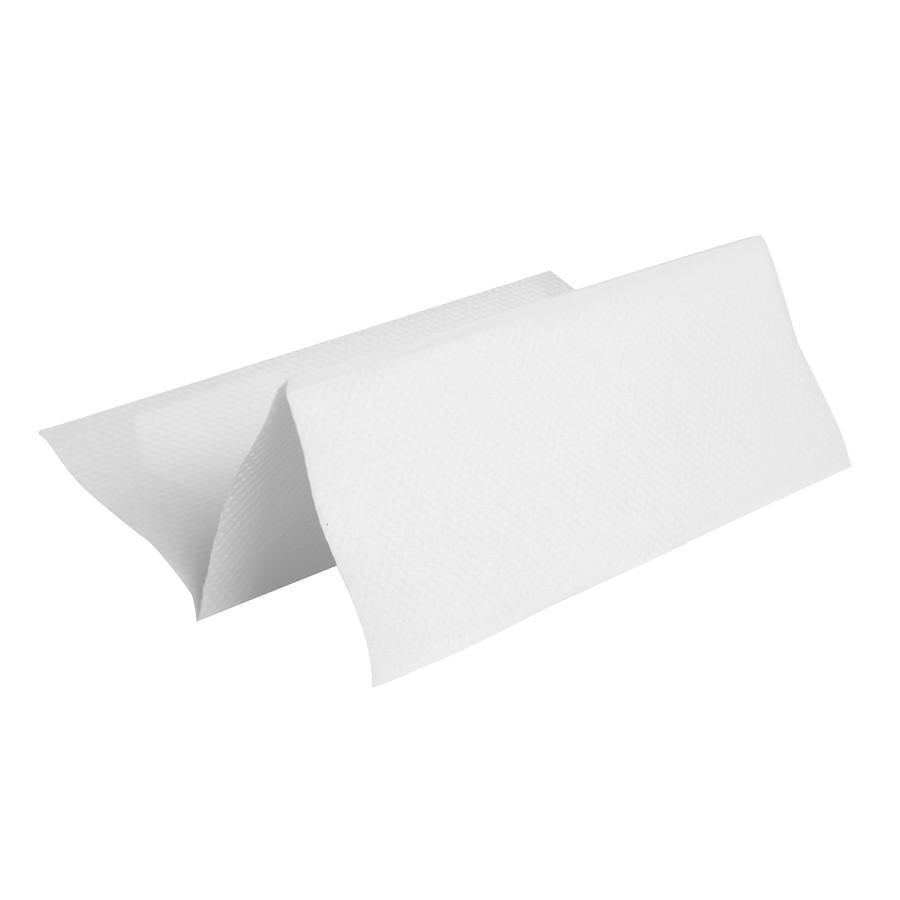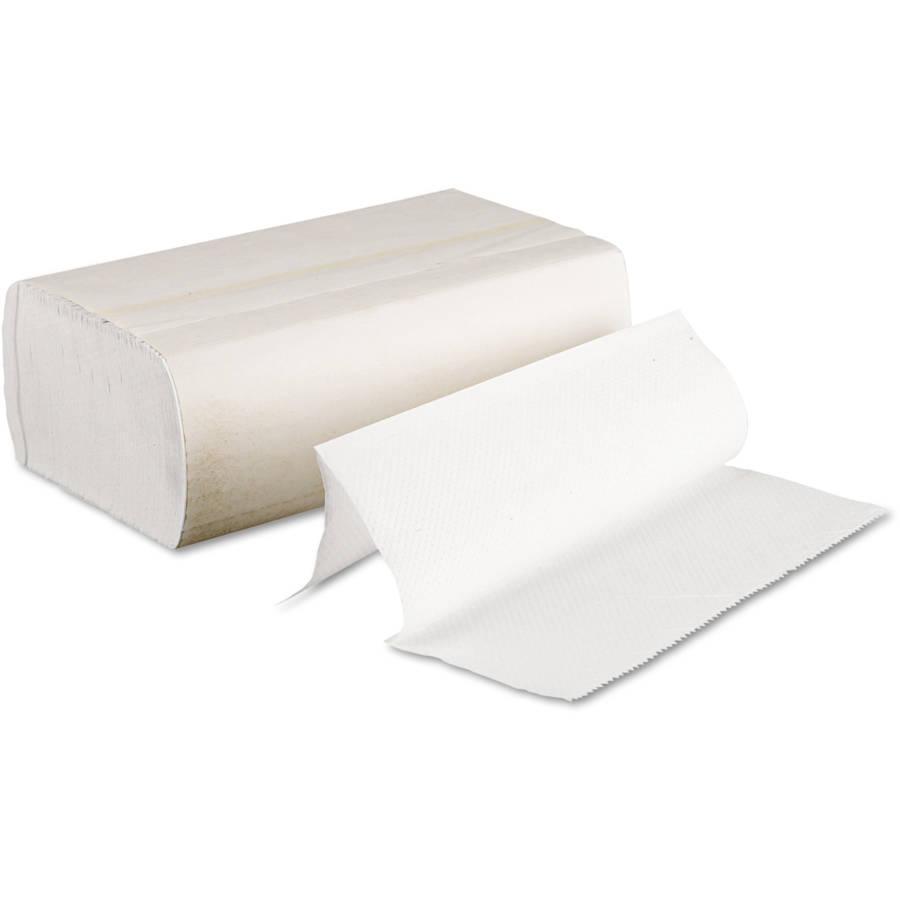The first image is the image on the left, the second image is the image on the right. Assess this claim about the two images: "At least one image features one accordion-folded paper towel in front of a stack of folded white paper towels wrapped in printed paper.". Correct or not? Answer yes or no. No. 